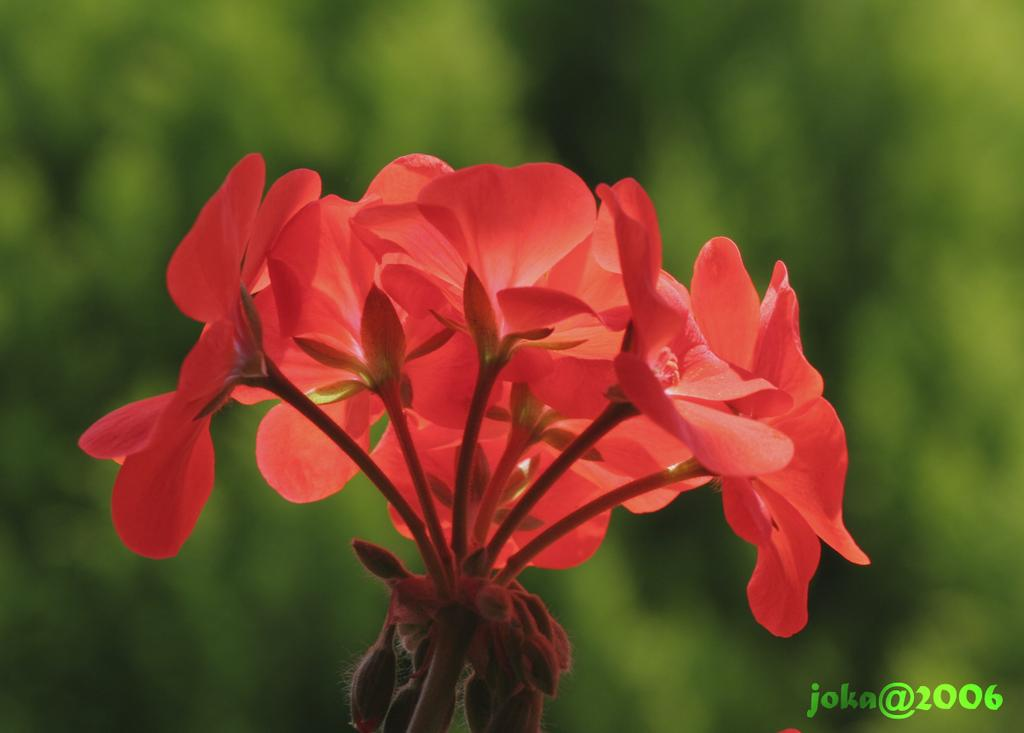What type of plant is featured in the image? There is a plant with orange flowers in the image. Is there any text or logo visible in the image? Yes, there is a watermark in the bottom right corner of the image. How would you describe the background of the image? The background of the image is blurred. What type of fear can be seen on the skin of the plant in the image? There is no fear or skin present in the image, as it features a plant with orange flowers and a watermark. 